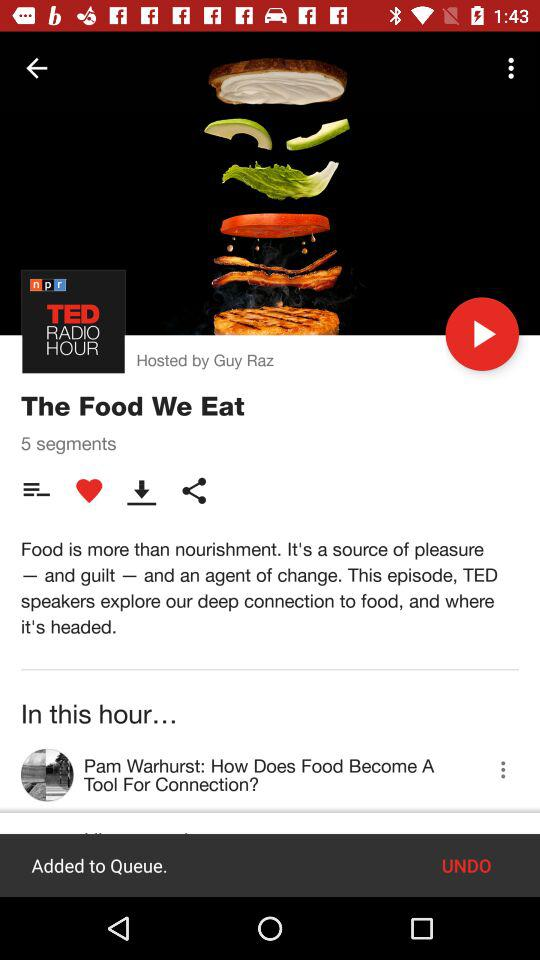Who is the host? The host is Guy Raz. 